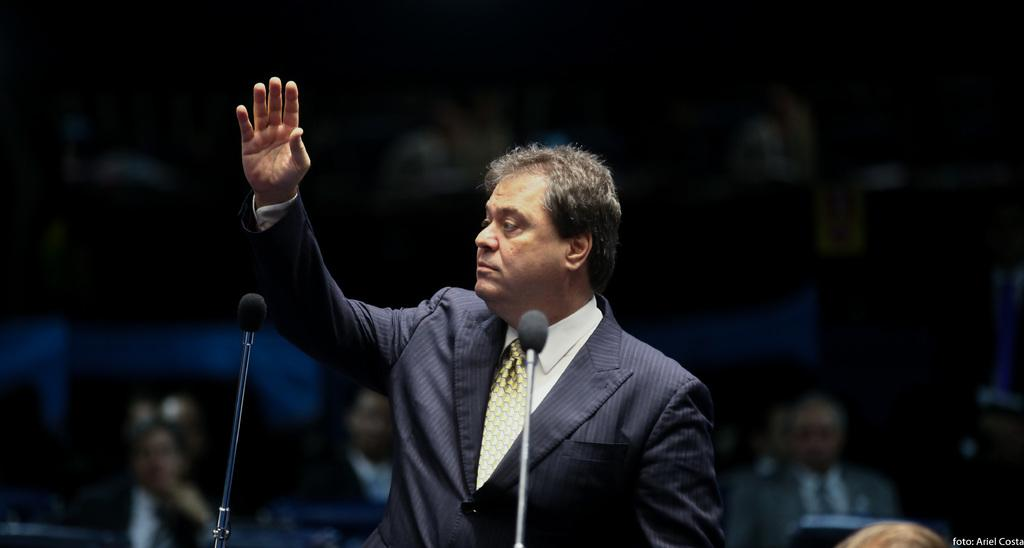What is the main subject of the image? The main subject of the image is a man. What is the man wearing in the image? The man is wearing a shirt, a tie, and a coat in the image. What can be seen in the foreground of the image? There are mics in the foreground of the image. What is visible in the background of the image? There are people in the background of the image. What type of form is the man filling out in the image? There is no form present in the image; the man is wearing a shirt, a tie, and a coat, and there are mics in the foreground. Can you tell me what type of guitar the man is playing in the image? There is no guitar present in the image; the man is wearing a shirt, a tie, and a coat, and there are mics in the foreground. 